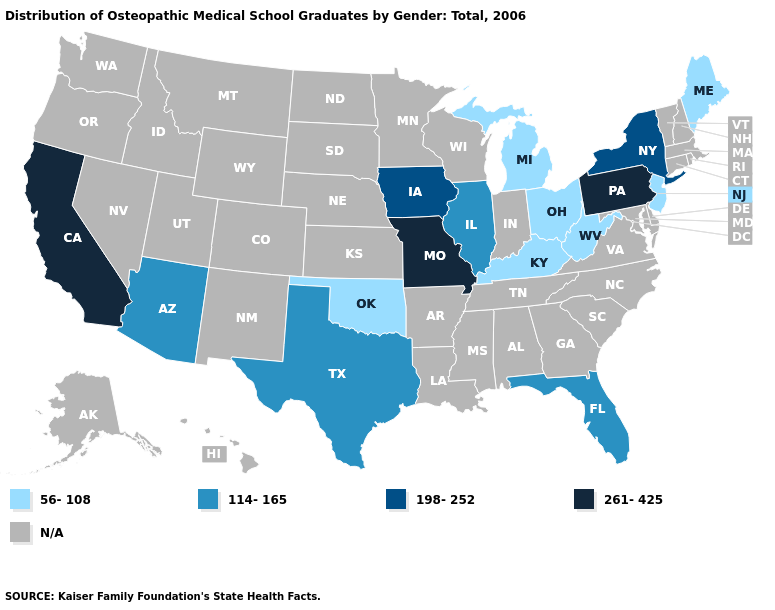Does the map have missing data?
Concise answer only. Yes. Which states hav the highest value in the South?
Give a very brief answer. Florida, Texas. Name the states that have a value in the range 198-252?
Short answer required. Iowa, New York. What is the highest value in states that border Colorado?
Write a very short answer. 114-165. What is the lowest value in the Northeast?
Answer briefly. 56-108. Does the map have missing data?
Concise answer only. Yes. What is the value of North Carolina?
Quick response, please. N/A. Name the states that have a value in the range 261-425?
Answer briefly. California, Missouri, Pennsylvania. Among the states that border Minnesota , which have the highest value?
Answer briefly. Iowa. Does the first symbol in the legend represent the smallest category?
Short answer required. Yes. Which states have the highest value in the USA?
Quick response, please. California, Missouri, Pennsylvania. What is the value of Georgia?
Quick response, please. N/A. What is the lowest value in the USA?
Concise answer only. 56-108. 